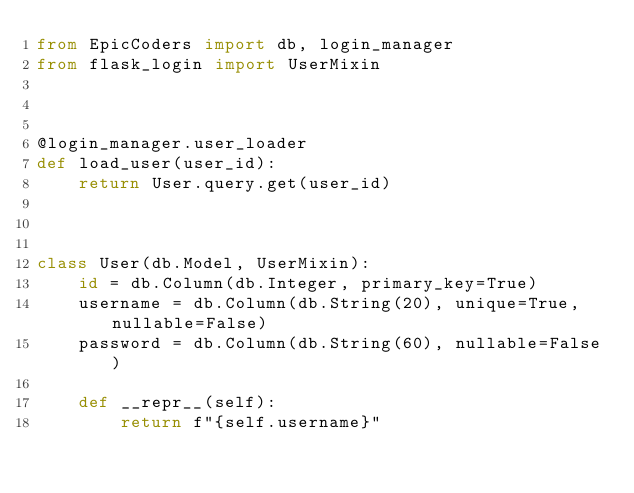<code> <loc_0><loc_0><loc_500><loc_500><_Python_>from EpicCoders import db, login_manager
from flask_login import UserMixin



@login_manager.user_loader
def load_user(user_id):
	return User.query.get(user_id)



class User(db.Model, UserMixin):
	id = db.Column(db.Integer, primary_key=True)
	username = db.Column(db.String(20), unique=True, nullable=False)
	password = db.Column(db.String(60), nullable=False)

	def __repr__(self):
		return f"{self.username}"</code> 